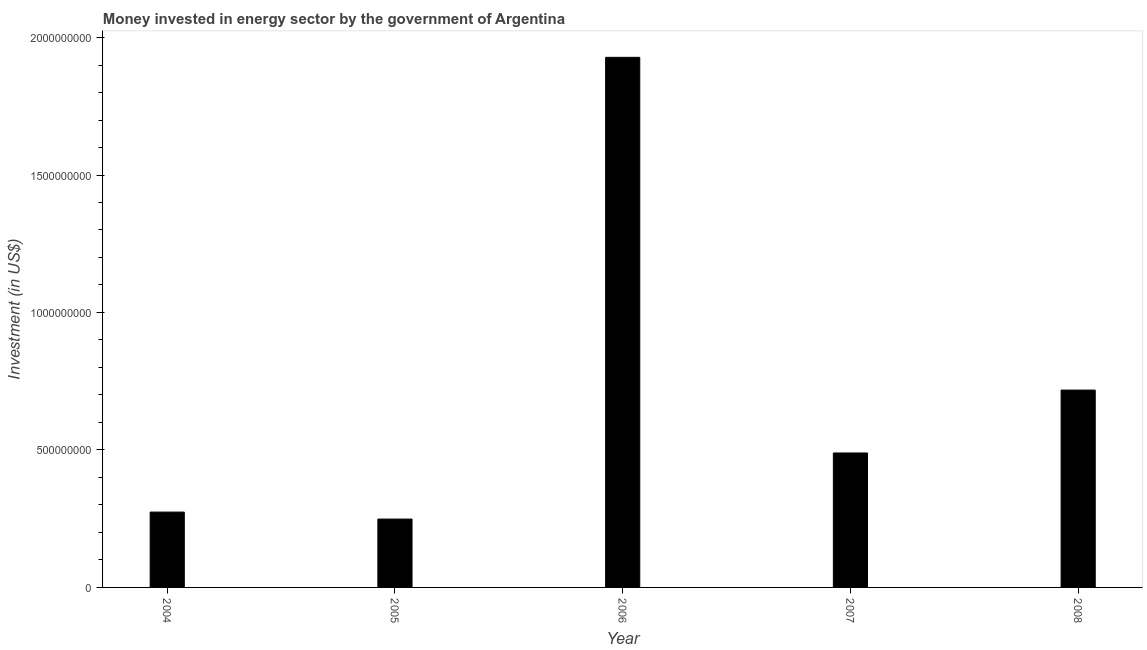Does the graph contain grids?
Provide a short and direct response. No. What is the title of the graph?
Offer a very short reply. Money invested in energy sector by the government of Argentina. What is the label or title of the X-axis?
Make the answer very short. Year. What is the label or title of the Y-axis?
Offer a terse response. Investment (in US$). What is the investment in energy in 2004?
Offer a very short reply. 2.74e+08. Across all years, what is the maximum investment in energy?
Offer a very short reply. 1.93e+09. Across all years, what is the minimum investment in energy?
Provide a short and direct response. 2.49e+08. What is the sum of the investment in energy?
Make the answer very short. 3.66e+09. What is the difference between the investment in energy in 2005 and 2007?
Your response must be concise. -2.40e+08. What is the average investment in energy per year?
Offer a very short reply. 7.31e+08. What is the median investment in energy?
Keep it short and to the point. 4.89e+08. Do a majority of the years between 2006 and 2005 (inclusive) have investment in energy greater than 1500000000 US$?
Provide a succinct answer. No. What is the ratio of the investment in energy in 2006 to that in 2008?
Provide a succinct answer. 2.69. Is the difference between the investment in energy in 2004 and 2005 greater than the difference between any two years?
Your answer should be very brief. No. What is the difference between the highest and the second highest investment in energy?
Your response must be concise. 1.21e+09. What is the difference between the highest and the lowest investment in energy?
Your response must be concise. 1.68e+09. How many bars are there?
Your answer should be compact. 5. How many years are there in the graph?
Give a very brief answer. 5. What is the Investment (in US$) in 2004?
Your answer should be compact. 2.74e+08. What is the Investment (in US$) of 2005?
Provide a succinct answer. 2.49e+08. What is the Investment (in US$) in 2006?
Your response must be concise. 1.93e+09. What is the Investment (in US$) of 2007?
Your answer should be compact. 4.89e+08. What is the Investment (in US$) of 2008?
Provide a short and direct response. 7.18e+08. What is the difference between the Investment (in US$) in 2004 and 2005?
Give a very brief answer. 2.54e+07. What is the difference between the Investment (in US$) in 2004 and 2006?
Your answer should be very brief. -1.65e+09. What is the difference between the Investment (in US$) in 2004 and 2007?
Your response must be concise. -2.15e+08. What is the difference between the Investment (in US$) in 2004 and 2008?
Make the answer very short. -4.44e+08. What is the difference between the Investment (in US$) in 2005 and 2006?
Offer a terse response. -1.68e+09. What is the difference between the Investment (in US$) in 2005 and 2007?
Provide a short and direct response. -2.40e+08. What is the difference between the Investment (in US$) in 2005 and 2008?
Ensure brevity in your answer.  -4.69e+08. What is the difference between the Investment (in US$) in 2006 and 2007?
Provide a short and direct response. 1.44e+09. What is the difference between the Investment (in US$) in 2006 and 2008?
Your answer should be very brief. 1.21e+09. What is the difference between the Investment (in US$) in 2007 and 2008?
Make the answer very short. -2.29e+08. What is the ratio of the Investment (in US$) in 2004 to that in 2005?
Your answer should be very brief. 1.1. What is the ratio of the Investment (in US$) in 2004 to that in 2006?
Provide a succinct answer. 0.14. What is the ratio of the Investment (in US$) in 2004 to that in 2007?
Give a very brief answer. 0.56. What is the ratio of the Investment (in US$) in 2004 to that in 2008?
Your answer should be compact. 0.38. What is the ratio of the Investment (in US$) in 2005 to that in 2006?
Make the answer very short. 0.13. What is the ratio of the Investment (in US$) in 2005 to that in 2007?
Provide a succinct answer. 0.51. What is the ratio of the Investment (in US$) in 2005 to that in 2008?
Make the answer very short. 0.35. What is the ratio of the Investment (in US$) in 2006 to that in 2007?
Give a very brief answer. 3.94. What is the ratio of the Investment (in US$) in 2006 to that in 2008?
Your answer should be compact. 2.69. What is the ratio of the Investment (in US$) in 2007 to that in 2008?
Your answer should be very brief. 0.68. 